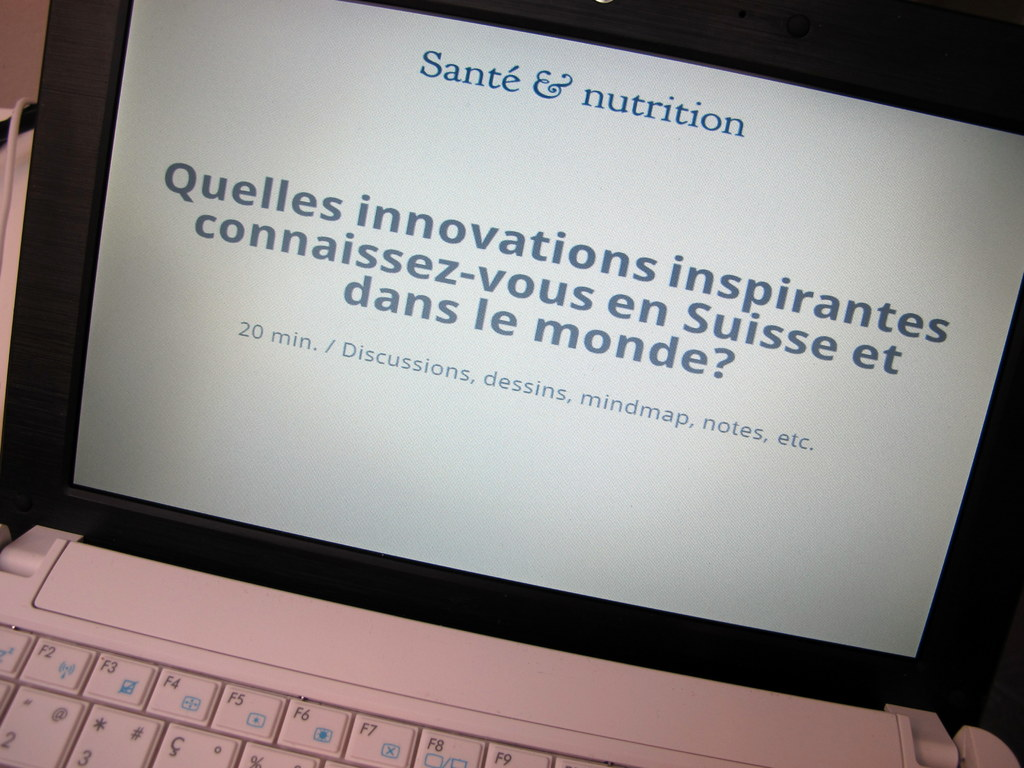What's happening in the scene? The image displays a laptop screen featuring a presentation slide in French. The slide is titled "Santé & nutrition", translating to "Health & Nutrition". It poses a question to the audience, asking them to discuss inspiring innovations they know of in Switzerland and around the world in the field of health and nutrition. The slide indicates that the discussion will last for 20 minutes. It encourages participants to use various methods such as drawings, mindmaps, and notes to contribute to the discussion. 